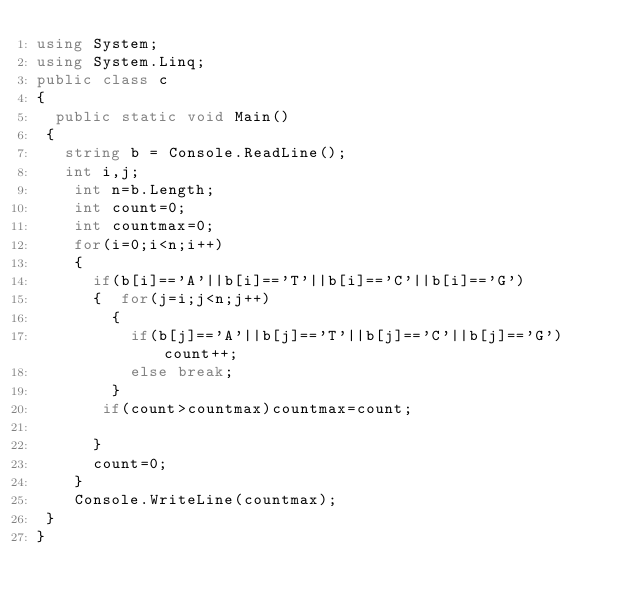Convert code to text. <code><loc_0><loc_0><loc_500><loc_500><_C#_>using System;
using System.Linq;
public class c
{
  public static void Main()
 {
   string b = Console.ReadLine();
   int i,j;
    int n=b.Length;
    int count=0;
    int countmax=0;
    for(i=0;i<n;i++)
    {
      if(b[i]=='A'||b[i]=='T'||b[i]=='C'||b[i]=='G')
      {  for(j=i;j<n;j++)
        {
          if(b[j]=='A'||b[j]=='T'||b[j]=='C'||b[j]=='G')count++;
          else break;
        }
       if(count>countmax)countmax=count;
      
      }
      count=0;
    }
    Console.WriteLine(countmax);
 }
}</code> 